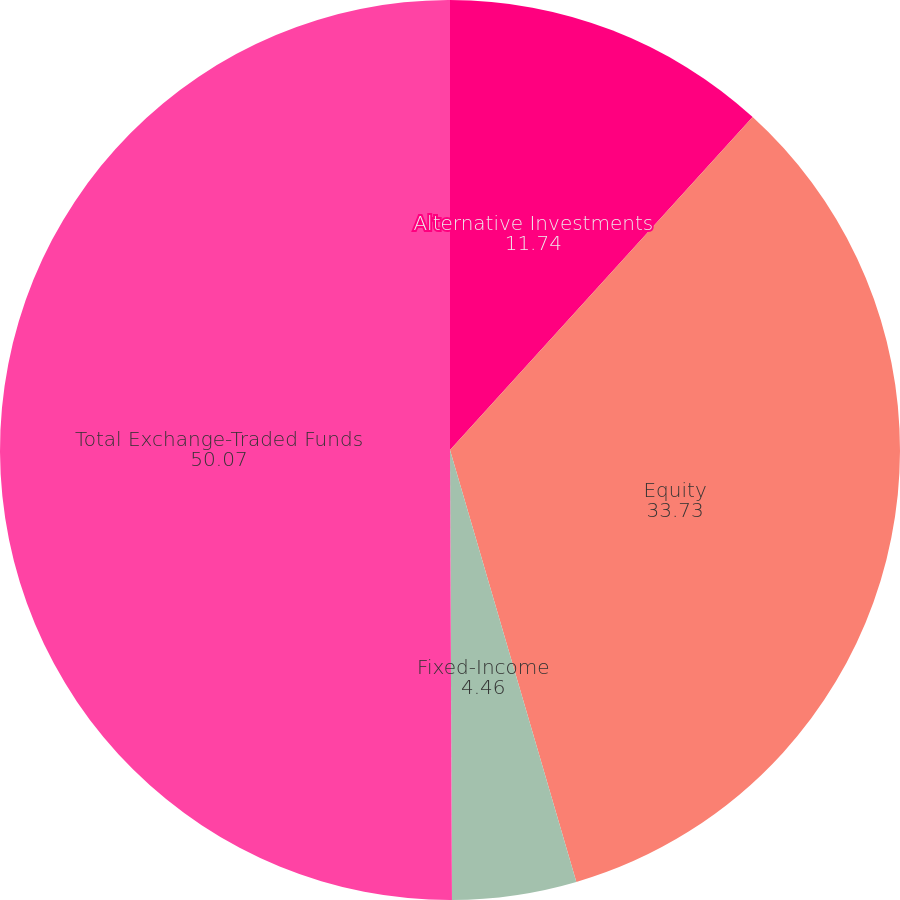Convert chart to OTSL. <chart><loc_0><loc_0><loc_500><loc_500><pie_chart><fcel>Alternative Investments<fcel>Equity<fcel>Fixed-Income<fcel>Total Exchange-Traded Funds<nl><fcel>11.74%<fcel>33.73%<fcel>4.46%<fcel>50.07%<nl></chart> 